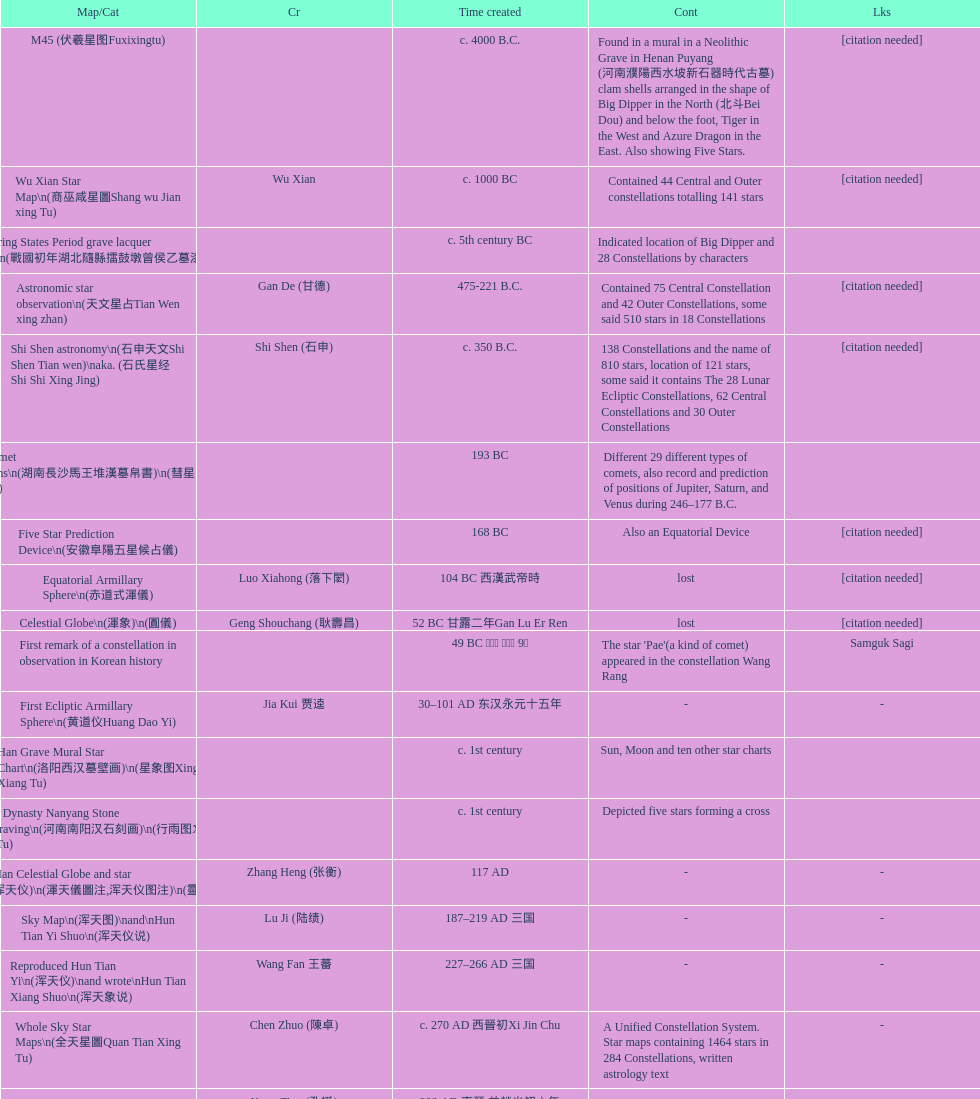What is the designation of the earliest map/catalog? M45. 